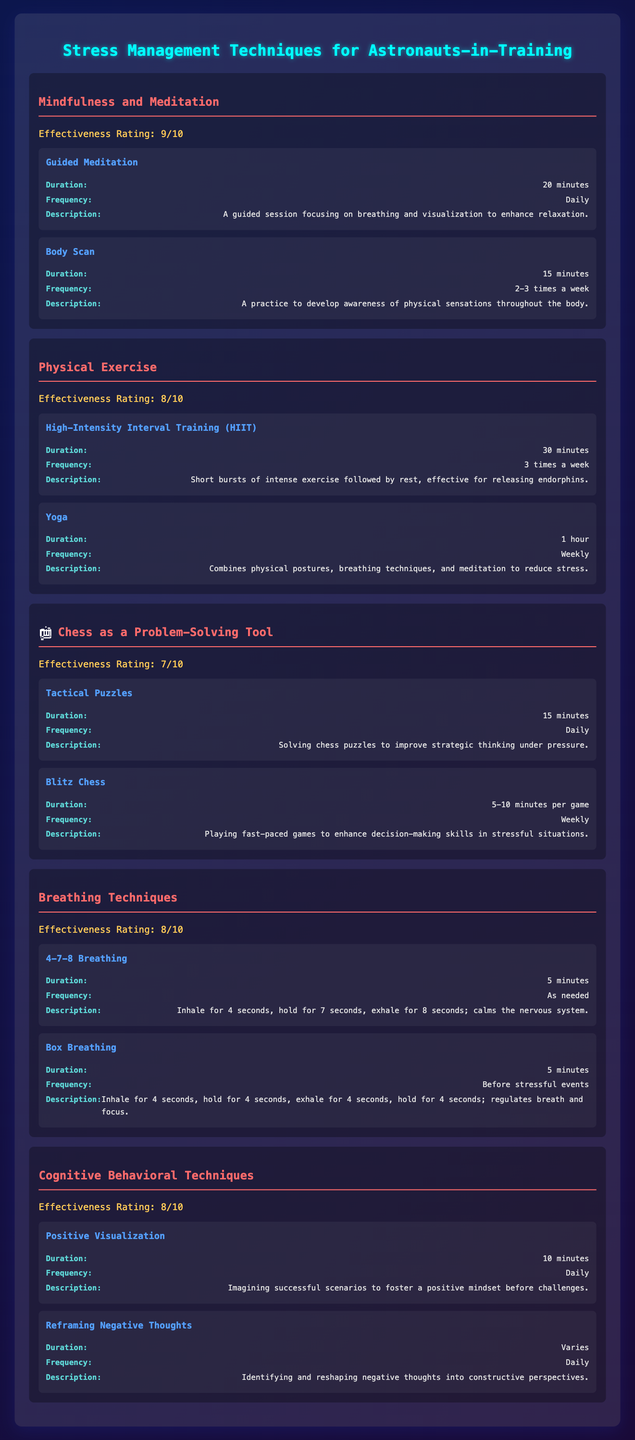What is the effectiveness rating of Mindfulness and Meditation? The rating is clearly mentioned in the table next to the technique "Mindfulness and Meditation," which states it has an effectiveness rating of 9.
Answer: 9 How often should Guided Meditation be practiced? Under the "Mindfulness and Meditation" section, it specifies that Guided Meditation should be practiced Daily.
Answer: Daily Which technique has the highest effectiveness rating? Comparing the effectiveness ratings of all techniques, "Mindfulness and Meditation" has the highest rating at 9.
Answer: Mindfulness and Meditation How many techniques are listed under Breathing Techniques? The "Breathing Techniques" section lists 2 techniques: "4-7-8 Breathing" and "Box Breathing."
Answer: 2 What is the average effectiveness rating of all the stress management techniques listed? The effectiveness ratings are 9, 8, 7, 8, and 8. Calculating the average: (9 + 8 + 7 + 8 + 8) / 5 = 8.
Answer: 8 Is Tactical Puzzles practiced weekly? The frequency for "Tactical Puzzles" is listed as Daily, not weekly. Therefore, the answer is No.
Answer: No Which technique requires the shortest duration? The shortest duration listed is for "4-7-8 Breathing," which takes 5 minutes, less than any other durations in the table.
Answer: 5 minutes If someone practices Yoga weekly and High-Intensity Interval Training 3 times a week, how many sessions in total do they practice per week? Yoga counts as 1 session per week, and HIIT as 3 sessions per week. Adding them together gives 1 + 3 = 4.
Answer: 4 What is the description provided for Box Breathing? The description states that it involves inhaling for 4 seconds, holding for 4 seconds, exhaling for 4 seconds, and holding for 4 seconds to regulate breath and focus.
Answer: Inhale for 4 seconds, hold for 4 seconds, exhale for 4 seconds, hold for 4 seconds; regulates breath and focus 